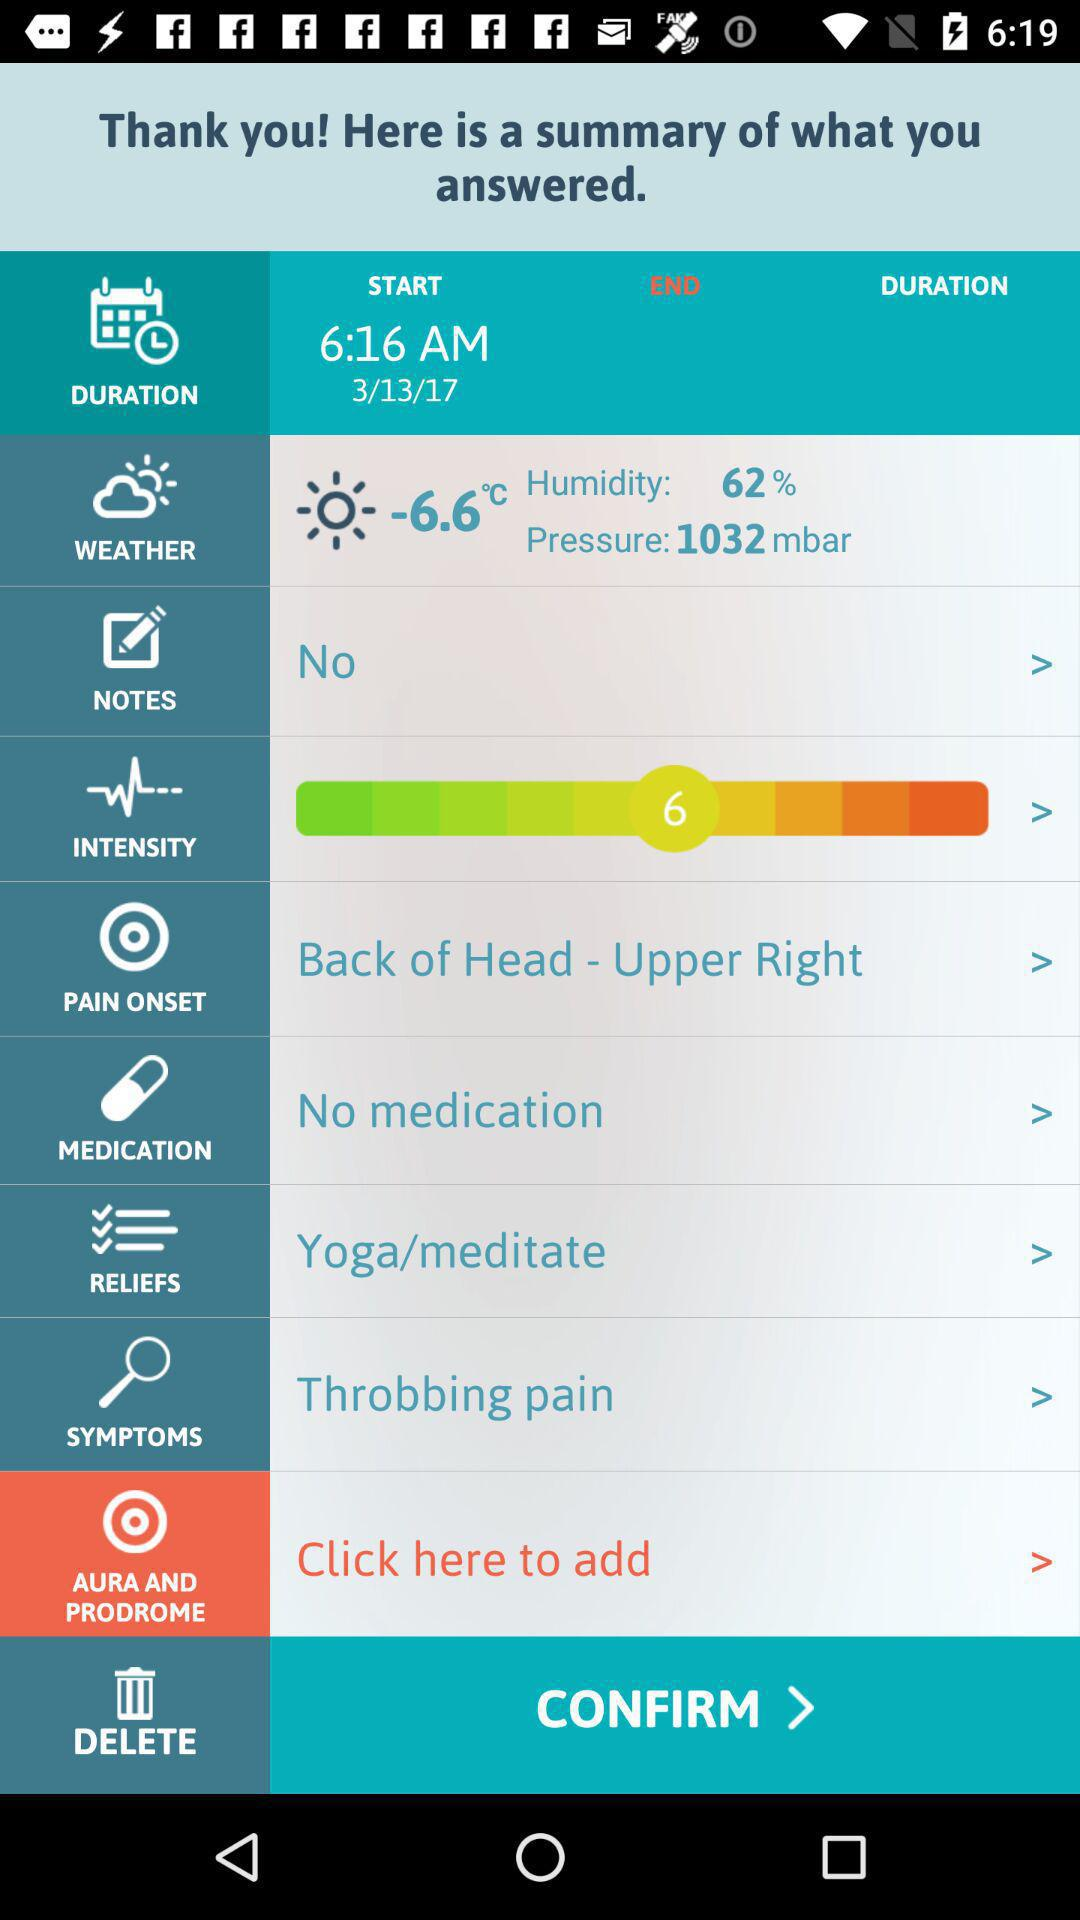For which item is the "Throbbing pain" option selected? The "Throbbing pain" option is selected for the "SYMPTOMS". 